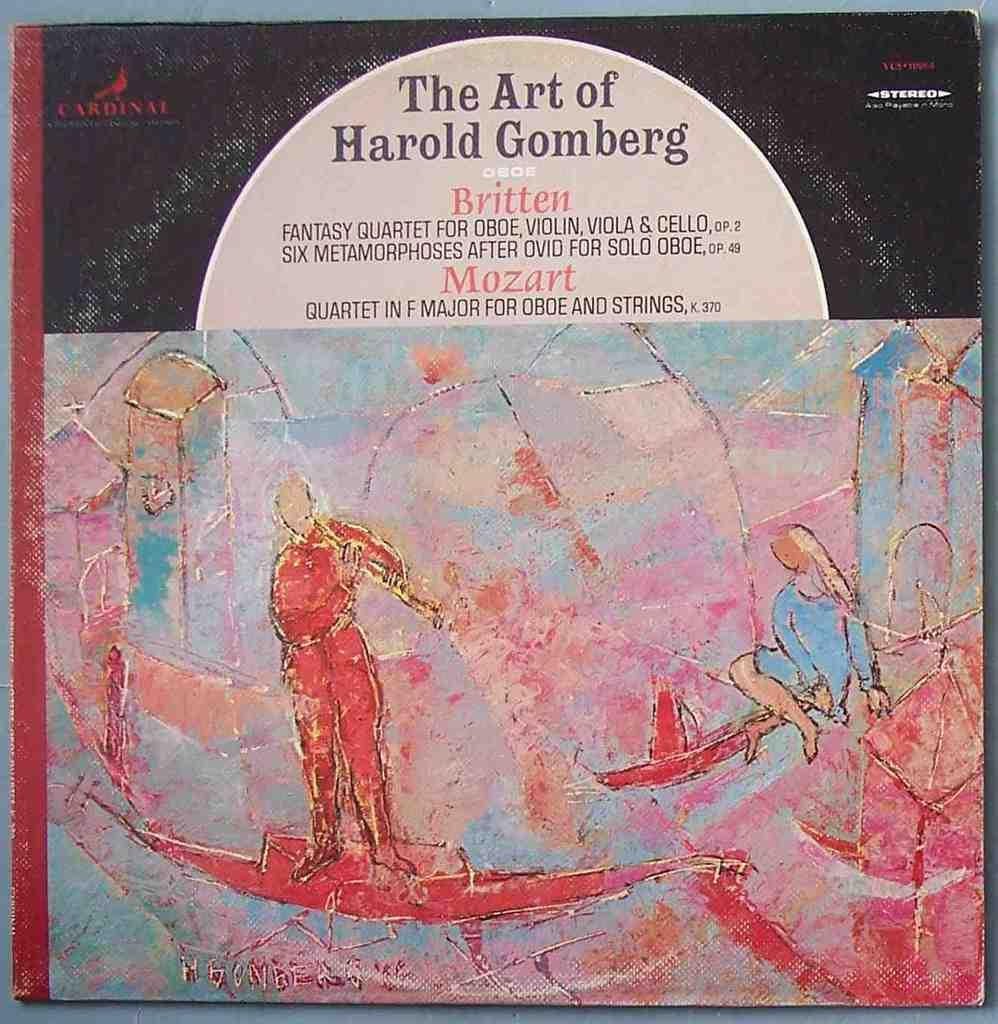<image>
Present a compact description of the photo's key features. a painting with lots of red and blue colors by harold gomberg 